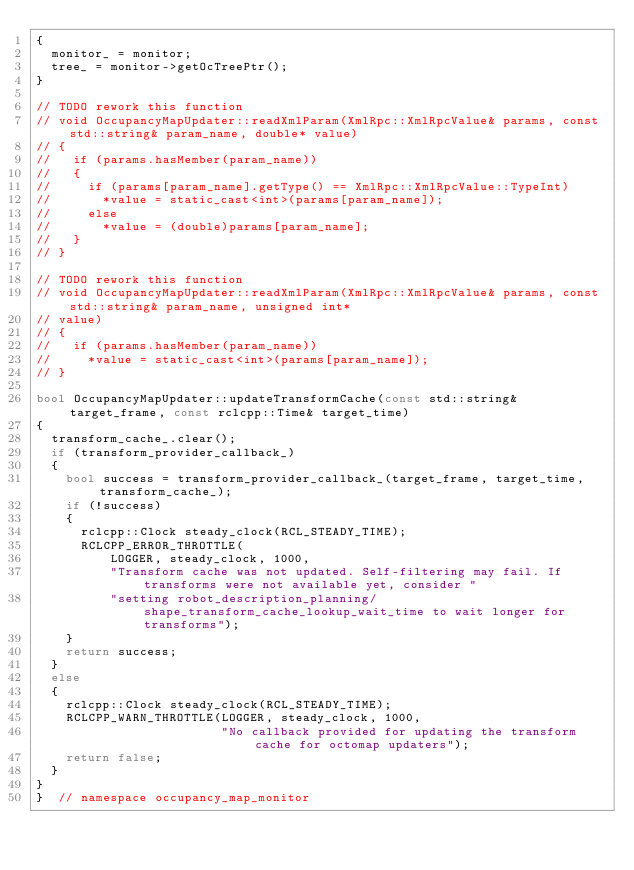<code> <loc_0><loc_0><loc_500><loc_500><_C++_>{
  monitor_ = monitor;
  tree_ = monitor->getOcTreePtr();
}

// TODO rework this function
// void OccupancyMapUpdater::readXmlParam(XmlRpc::XmlRpcValue& params, const std::string& param_name, double* value)
// {
//   if (params.hasMember(param_name))
//   {
//     if (params[param_name].getType() == XmlRpc::XmlRpcValue::TypeInt)
//       *value = static_cast<int>(params[param_name]);
//     else
//       *value = (double)params[param_name];
//   }
// }

// TODO rework this function
// void OccupancyMapUpdater::readXmlParam(XmlRpc::XmlRpcValue& params, const std::string& param_name, unsigned int*
// value)
// {
//   if (params.hasMember(param_name))
//     *value = static_cast<int>(params[param_name]);
// }

bool OccupancyMapUpdater::updateTransformCache(const std::string& target_frame, const rclcpp::Time& target_time)
{
  transform_cache_.clear();
  if (transform_provider_callback_)
  {
    bool success = transform_provider_callback_(target_frame, target_time, transform_cache_);
    if (!success)
    {
      rclcpp::Clock steady_clock(RCL_STEADY_TIME);
      RCLCPP_ERROR_THROTTLE(
          LOGGER, steady_clock, 1000,
          "Transform cache was not updated. Self-filtering may fail. If transforms were not available yet, consider "
          "setting robot_description_planning/shape_transform_cache_lookup_wait_time to wait longer for transforms");
    }
    return success;
  }
  else
  {
    rclcpp::Clock steady_clock(RCL_STEADY_TIME);
    RCLCPP_WARN_THROTTLE(LOGGER, steady_clock, 1000,
                         "No callback provided for updating the transform cache for octomap updaters");
    return false;
  }
}
}  // namespace occupancy_map_monitor
</code> 